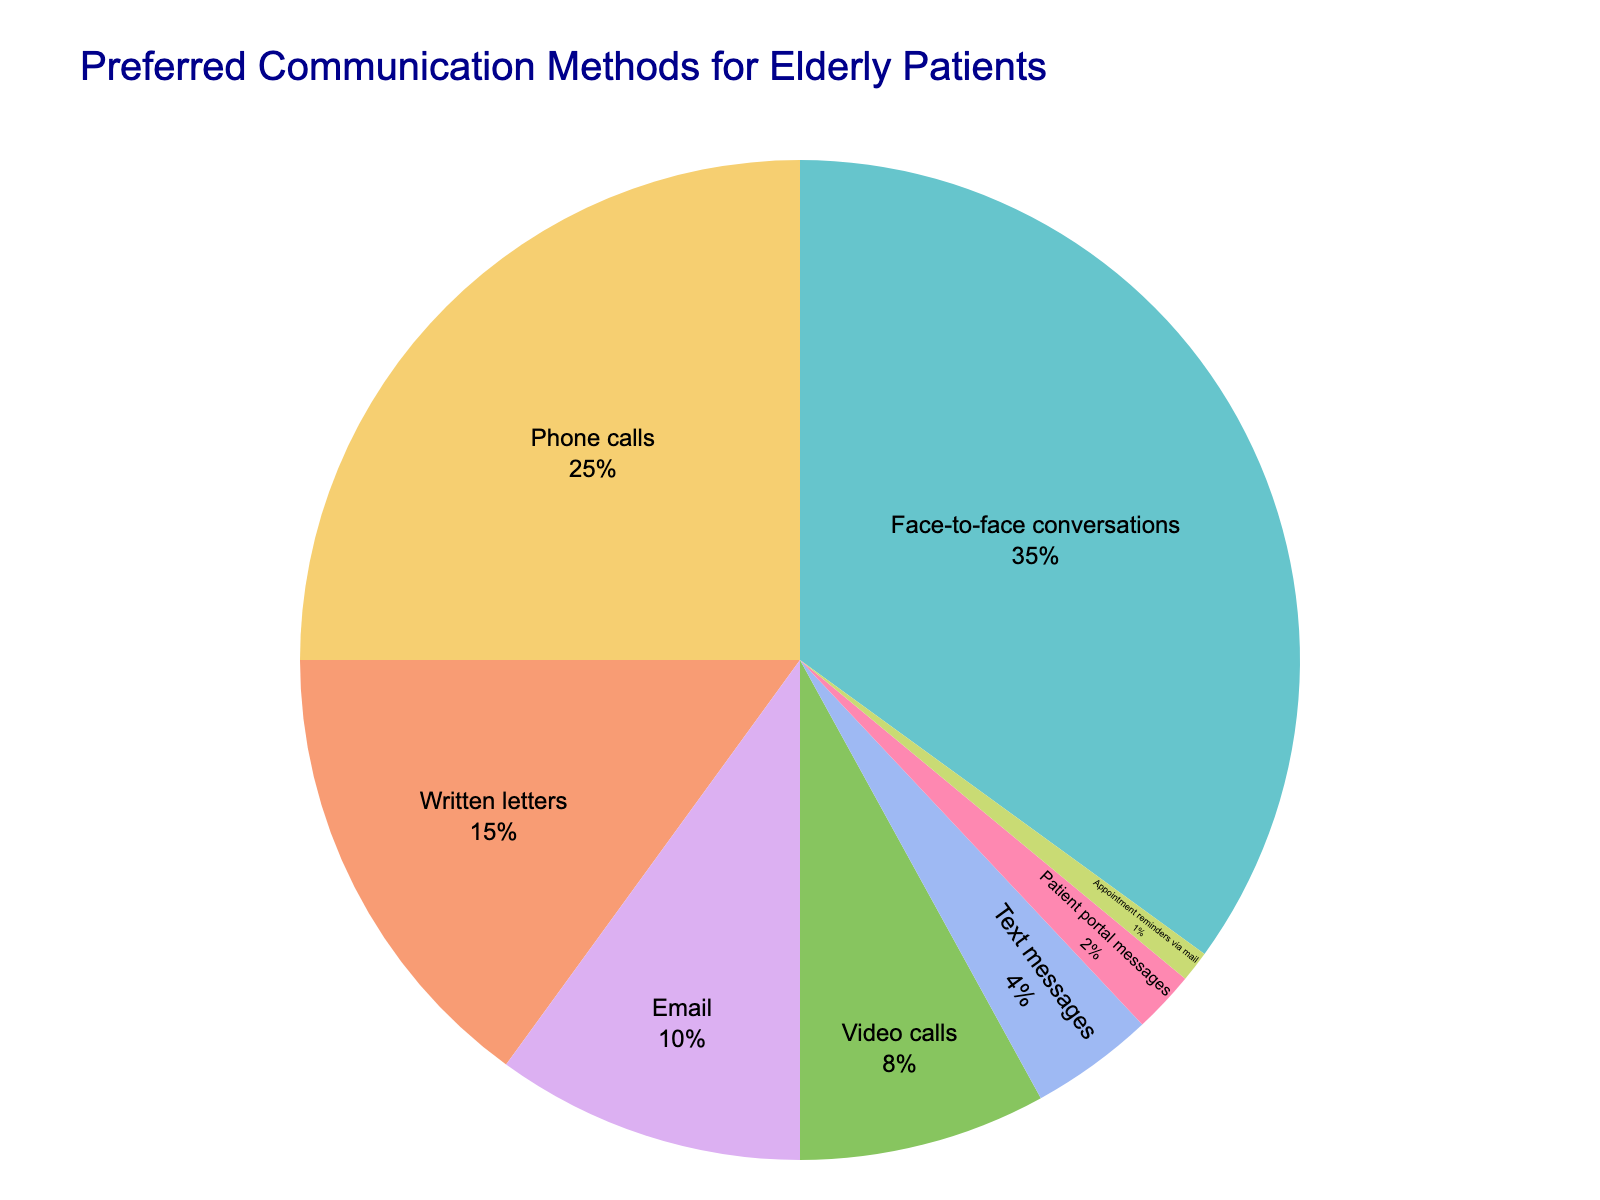What's the most preferred communication method for elderly patients in healthcare settings? The most preferred method can be identified by finding the highest percentage in the pie chart. "Face-to-face conversations" represents 35%, which is the largest segment.
Answer: Face-to-face conversations Which communication method is the least preferred? To determine the least preferred method, we look for the smallest percentage in the pie chart. The "Appointment reminders via mail" method shows 1%, which is the lowest.
Answer: Appointment reminders via mail How much more preferred are phone calls compared to text messages? First, identify the percentages for phone calls (25%) and text messages (4%) from the pie chart. Then subtract the smaller percentage from the larger one: 25% - 4% = 21%.
Answer: 21% What is the combined percentage of elderly patients who prefer email and video calls? Add the percentages of email (10%) and video calls (8%) from the pie chart: 10% + 8% = 18%.
Answer: 18% Which two communication methods combined make up exactly half of the preferences? Sum the percentages of different combinations until a pair sums to 50%. "Face-to-face conversations" is 35% and "Phone calls" is 25%. Combined they are 35% + 25% = 60%. "Face-to-face conversations" with "Written letters" is (35% + 15% = 50%).
Answer: Face-to-face conversations and Written letters Is the usage of text messages more preferred than patient portal messages? Compare the percentages of text messages (4%) and patient portal messages (2%) from the pie chart. 4% is greater than 2%, indicating text messages are more preferred.
Answer: Yes What percentage of elderly patients prefer either phone calls or written letters? Add the percentages for phone calls (25%) and written letters (15%) from the pie chart: 25% + 15% = 40%.
Answer: 40% If we combine all digital communication methods (email, video calls, text messages, patient portal messages), what is their total preference percentage? Digital communication methods include email (10%), video calls (8%), text messages (4%), and patient portal messages (2%). Sum these percentages: 10% + 8% + 4% + 2% = 24%.
Answer: 24% Which communication method has a percentage closest to one-third of the pie chart? One-third of 100% is approximately 33.33%. From the pie chart, "Face-to-face conversations" at 35% is closest to one-third.
Answer: Face-to-face conversations What is the difference in preference between the most and least preferred communication methods? Identify the highest (Face-to-face conversations at 35%) and lowest (Appointment reminders via mail at 1%) percentages from the pie chart, then subtract the smallest from the largest: 35% - 1% = 34%.
Answer: 34% 